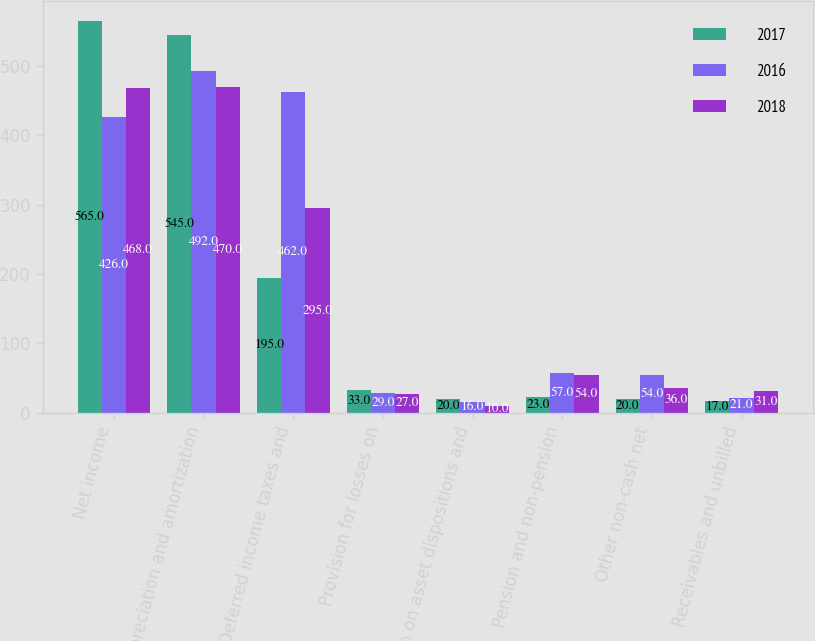Convert chart. <chart><loc_0><loc_0><loc_500><loc_500><stacked_bar_chart><ecel><fcel>Net income<fcel>Depreciation and amortization<fcel>Deferred income taxes and<fcel>Provision for losses on<fcel>Gain on asset dispositions and<fcel>Pension and non-pension<fcel>Other non-cash net<fcel>Receivables and unbilled<nl><fcel>2017<fcel>565<fcel>545<fcel>195<fcel>33<fcel>20<fcel>23<fcel>20<fcel>17<nl><fcel>2016<fcel>426<fcel>492<fcel>462<fcel>29<fcel>16<fcel>57<fcel>54<fcel>21<nl><fcel>2018<fcel>468<fcel>470<fcel>295<fcel>27<fcel>10<fcel>54<fcel>36<fcel>31<nl></chart> 